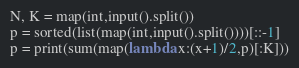Convert code to text. <code><loc_0><loc_0><loc_500><loc_500><_Python_>N, K = map(int,input().split())
p = sorted(list(map(int,input().split())))[::-1]
p = print(sum(map(lambda x:(x+1)/2,p)[:K]))
</code> 